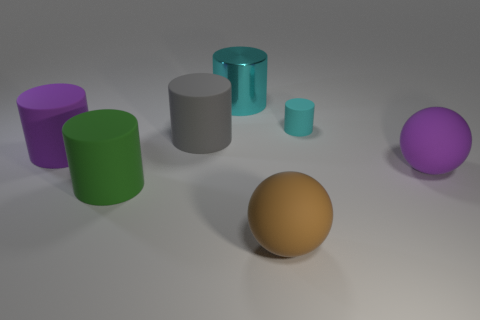Subtract all purple cylinders. How many cylinders are left? 4 Subtract all large gray matte cylinders. How many cylinders are left? 4 Subtract 1 cylinders. How many cylinders are left? 4 Subtract all yellow cylinders. Subtract all gray cubes. How many cylinders are left? 5 Add 2 brown matte balls. How many objects exist? 9 Subtract all cylinders. How many objects are left? 2 Subtract 0 red cubes. How many objects are left? 7 Subtract all large brown matte things. Subtract all big shiny things. How many objects are left? 5 Add 6 gray cylinders. How many gray cylinders are left? 7 Add 6 cyan metallic spheres. How many cyan metallic spheres exist? 6 